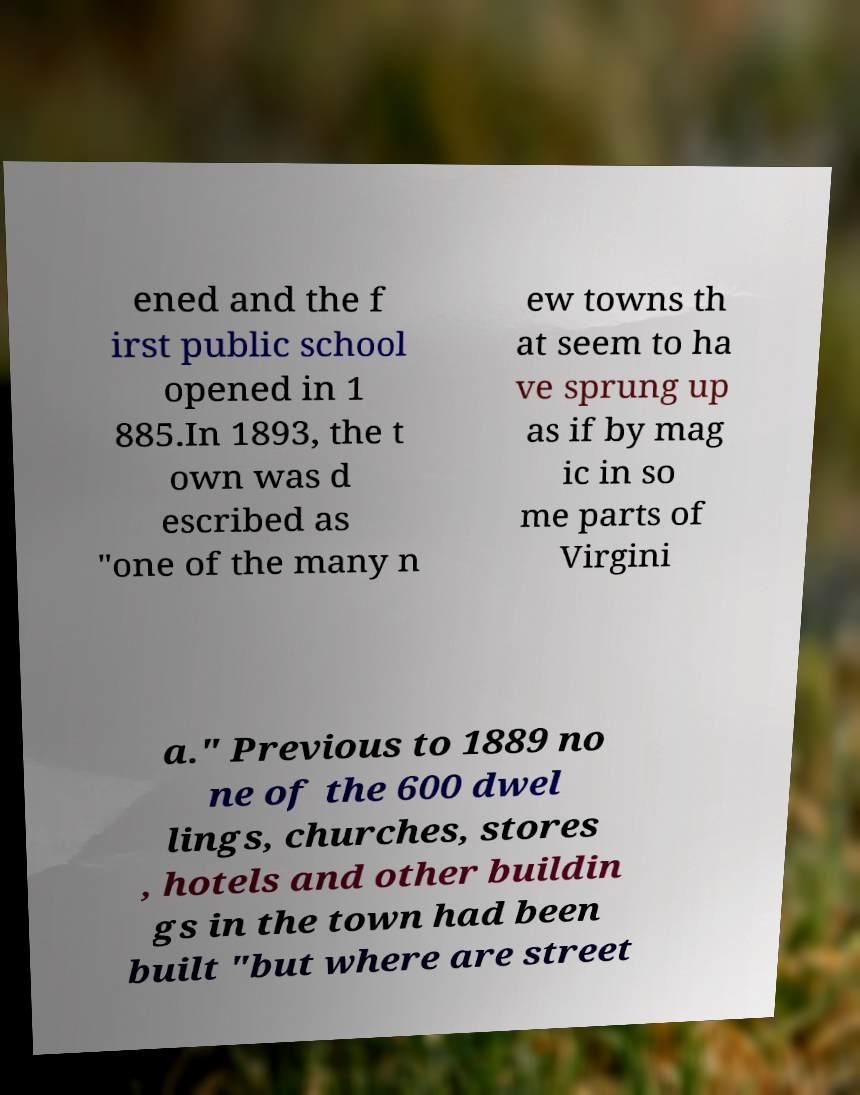Could you assist in decoding the text presented in this image and type it out clearly? ened and the f irst public school opened in 1 885.In 1893, the t own was d escribed as "one of the many n ew towns th at seem to ha ve sprung up as if by mag ic in so me parts of Virgini a." Previous to 1889 no ne of the 600 dwel lings, churches, stores , hotels and other buildin gs in the town had been built "but where are street 